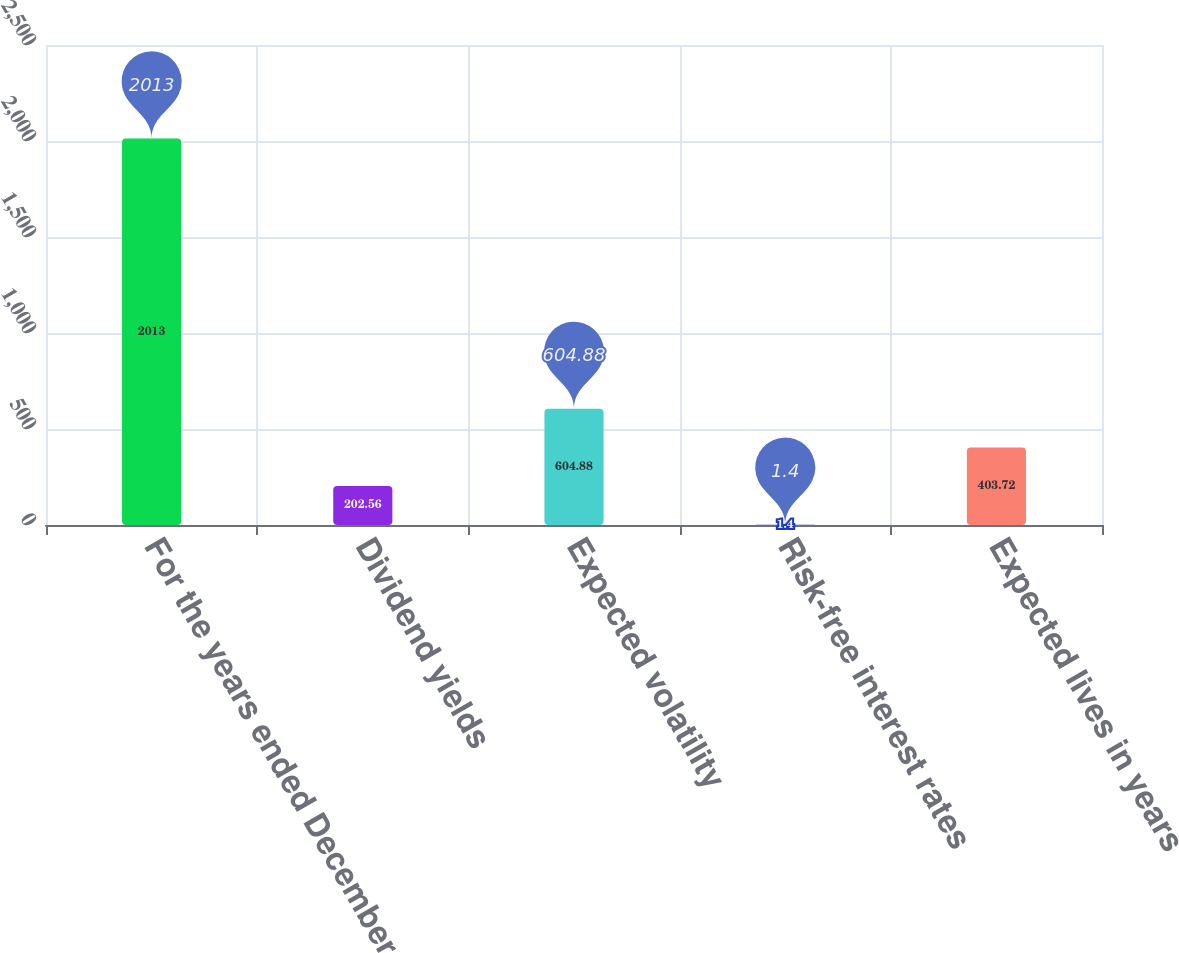<chart> <loc_0><loc_0><loc_500><loc_500><bar_chart><fcel>For the years ended December<fcel>Dividend yields<fcel>Expected volatility<fcel>Risk-free interest rates<fcel>Expected lives in years<nl><fcel>2013<fcel>202.56<fcel>604.88<fcel>1.4<fcel>403.72<nl></chart> 